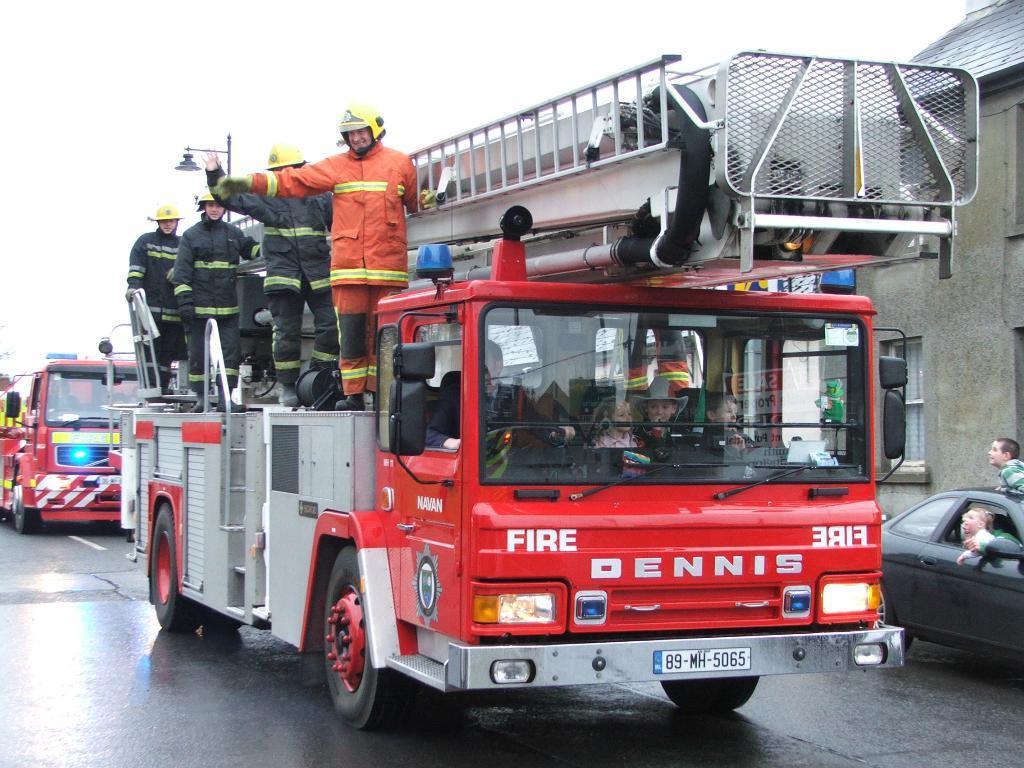Please provide a concise description of this image. This image consists of fire vehicles. There are some persons standing on that. There is a car on the right side. It is in black color. There are some persons sitting in that car. 